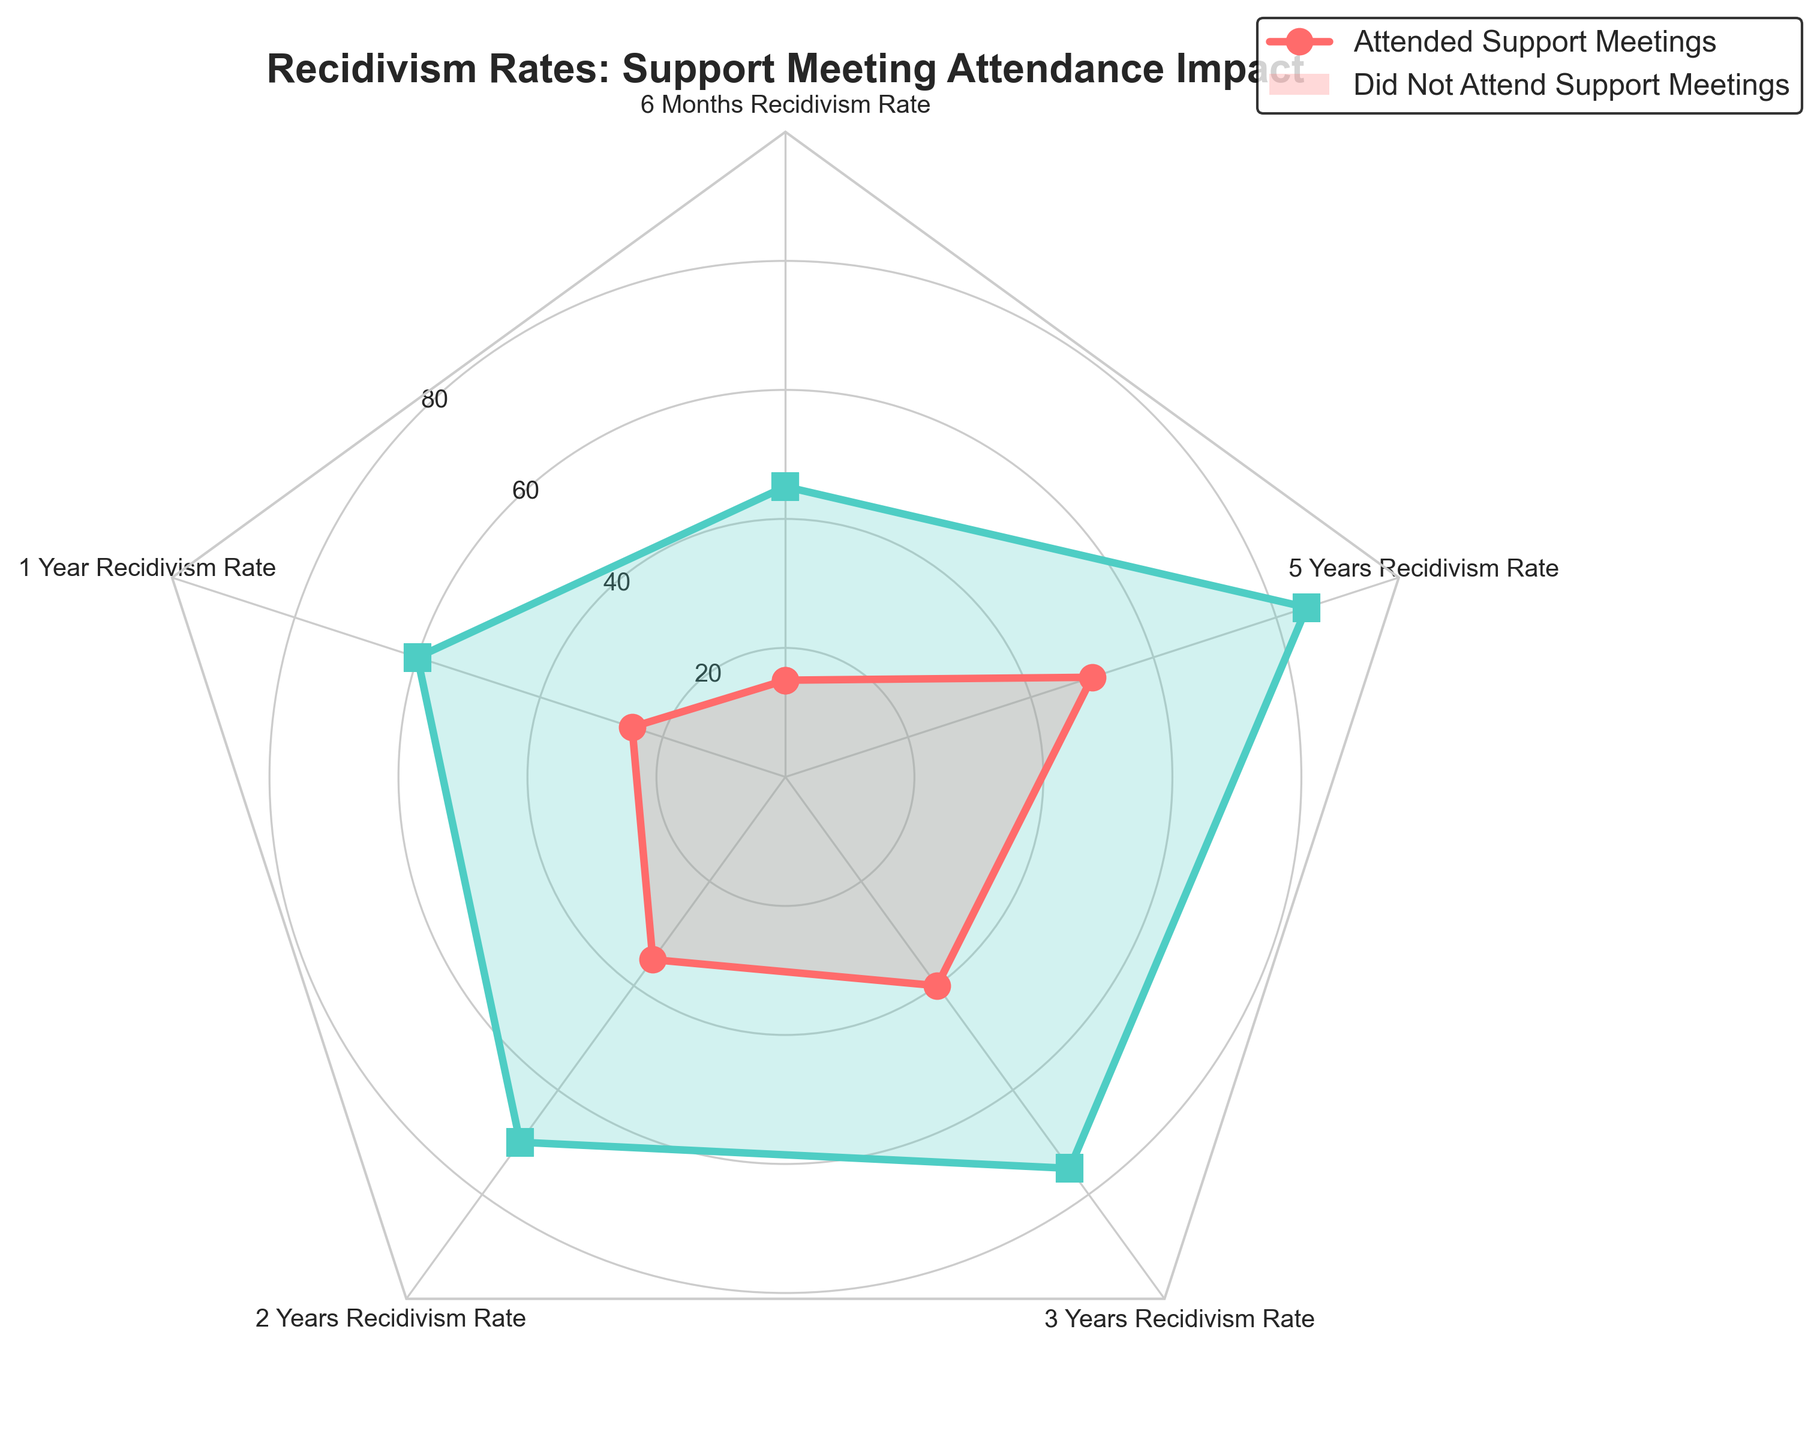Which category has the lowest recidivism rate for those who attended support meetings? Looking at the radar chart, the "6 Months Recidivism Rate" category has the lowest value for those who attended support meetings.
Answer: 6 Months Recidivism Rate What is the difference in recidivism rates at 1 year between those who attended and those who didn't attend support meetings? From the chart, the "1 Year Recidivism Rate" for those who attended support meetings is 25, and for those who didn't attend is 60. The difference is 60 - 25 = 35.
Answer: 35 What is the average recidivism rate at 2 years for those who did not attend support meetings? Since there's only one value for the 2 Years Recidivism Rate for those who didn't attend support meetings, which is 70, the average is just 70.
Answer: 70 Are the recidivism rates higher across all categories for those who did not attend support meetings, compared to those who attended? To answer this, compare each category's values. For each category, the rates for those who did not attend support meetings (45, 60, 70, 75, 85) are higher than for those who attended (15, 25, 35, 40, 50).
Answer: Yes What is the difference in recidivism rates at 5 years between the two groups? From the chart, the "5 Years Recidivism Rate" for those who attended support meetings is 50, and for those who didn't attend is 85. The difference is 85 - 50 = 35.
Answer: 35 What is the overall trend in recidivism rates for those who attended support meetings? The rates for those who attended support meetings increase over time, starting from the lowest at 6 months and reaching the highest at 5 years.
Answer: Increasing How much higher is the 3 Years Recidivism Rate for those who did not attend support meetings compared to those who attended? From the chart, the "3 Years Recidivism Rate" for those who attended support meetings is 40, and for those who didn't attend is 75. The difference is 75 - 40 = 35.
Answer: 35 In which category is the difference in recidivism rates between the two groups the largest? To find the largest difference, subtract the values of the "Attended Support Meetings" from the "Did Not Attend Support Meetings" for each category. The differences are: 30, 35, 35, 35, 35. The differences for 1, 3, and 5 years are equal at 35. So, the largest difference occurs in the categories of "1 Year Recidivism Rate," "3 Years Recidivism Rate," and "5 Years Recidivism Rate."
Answer: 1, 3, and 5 Years Recidivism Rate 